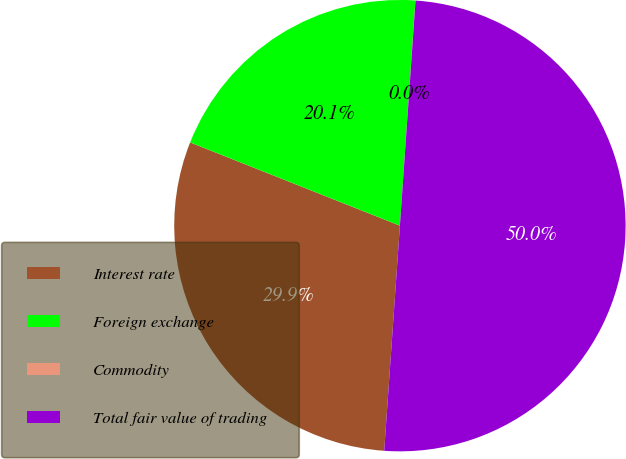Convert chart. <chart><loc_0><loc_0><loc_500><loc_500><pie_chart><fcel>Interest rate<fcel>Foreign exchange<fcel>Commodity<fcel>Total fair value of trading<nl><fcel>29.9%<fcel>20.08%<fcel>0.01%<fcel>50.0%<nl></chart> 